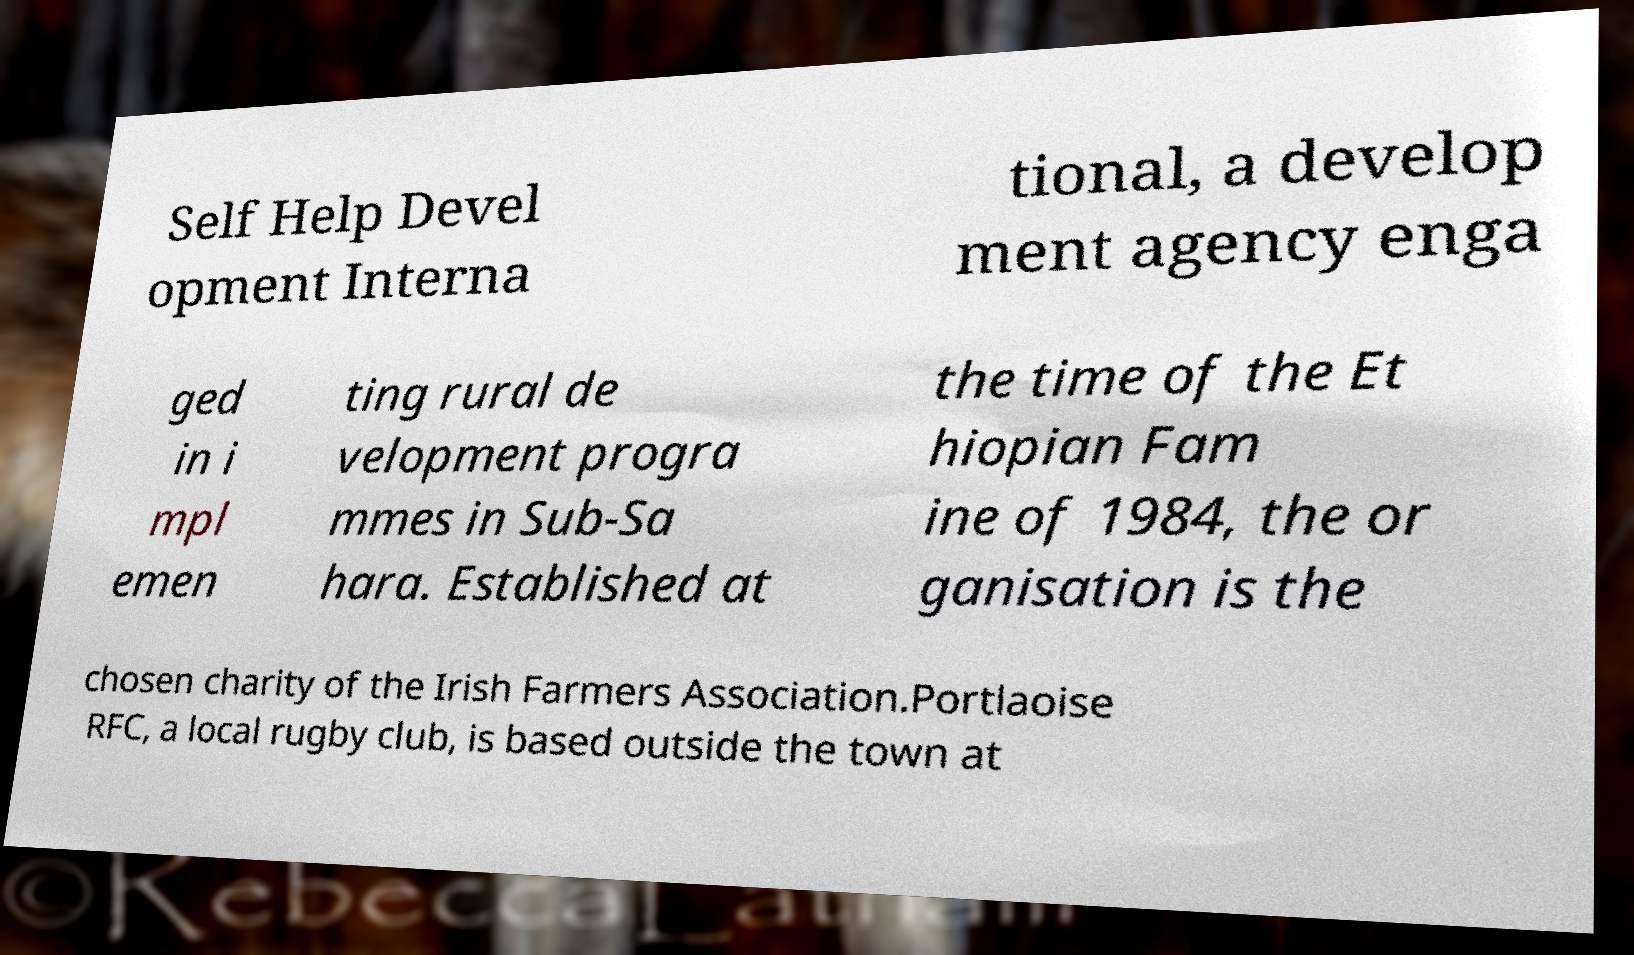Can you read and provide the text displayed in the image?This photo seems to have some interesting text. Can you extract and type it out for me? Self Help Devel opment Interna tional, a develop ment agency enga ged in i mpl emen ting rural de velopment progra mmes in Sub-Sa hara. Established at the time of the Et hiopian Fam ine of 1984, the or ganisation is the chosen charity of the Irish Farmers Association.Portlaoise RFC, a local rugby club, is based outside the town at 